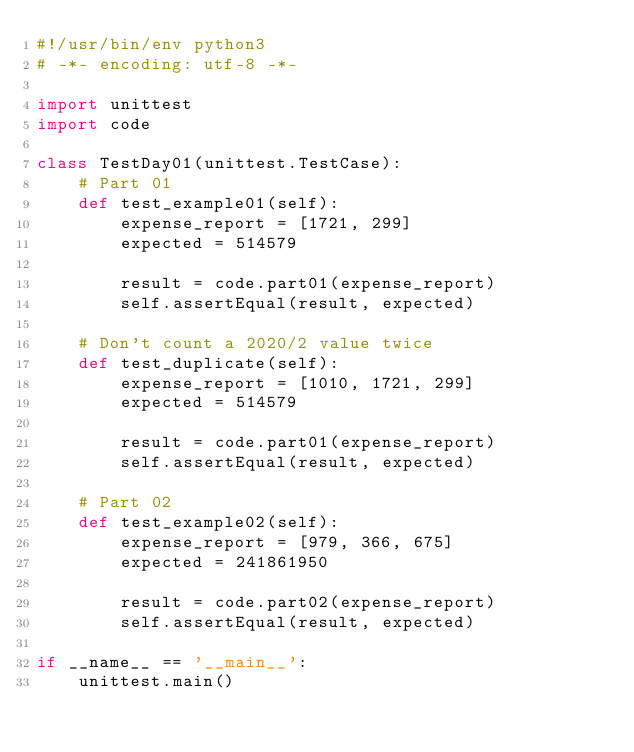<code> <loc_0><loc_0><loc_500><loc_500><_Python_>#!/usr/bin/env python3
# -*- encoding: utf-8 -*-

import unittest
import code

class TestDay01(unittest.TestCase):
    # Part 01
    def test_example01(self):
        expense_report = [1721, 299]
        expected = 514579

        result = code.part01(expense_report)
        self.assertEqual(result, expected)

    # Don't count a 2020/2 value twice
    def test_duplicate(self):
        expense_report = [1010, 1721, 299]
        expected = 514579

        result = code.part01(expense_report)
        self.assertEqual(result, expected)

    # Part 02
    def test_example02(self):
        expense_report = [979, 366, 675]
        expected = 241861950

        result = code.part02(expense_report)
        self.assertEqual(result, expected)

if __name__ == '__main__':
    unittest.main()
</code> 